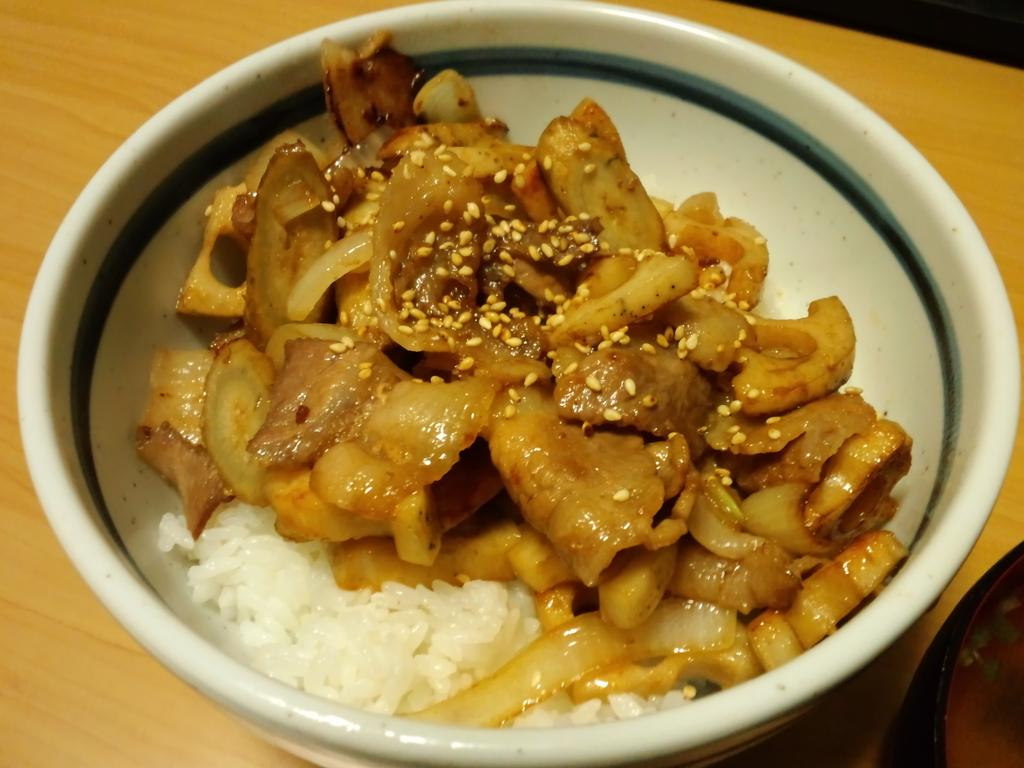What is the main piece of furniture in the image? There is a table in the image. What is placed on the table? There is a bowl on the table. What is inside the bowl? There is a food item inside the bowl. Can you see another bowl in the image? Yes, there is another bowl on the table, visible from the right corner. Is there steam coming out of the food item in the image? There is no steam visible in the image, and it cannot be determined if the food item is hot or cold. 